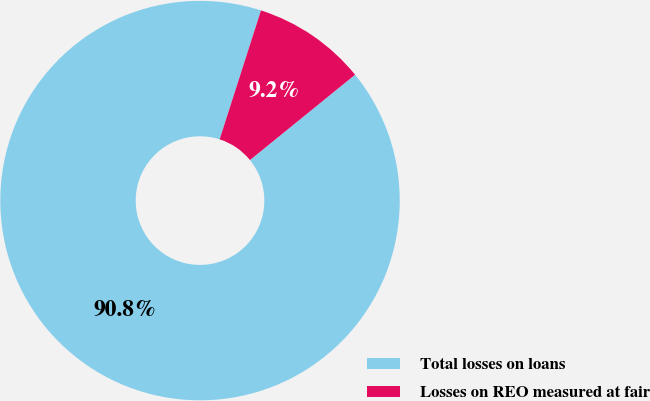Convert chart. <chart><loc_0><loc_0><loc_500><loc_500><pie_chart><fcel>Total losses on loans<fcel>Losses on REO measured at fair<nl><fcel>90.79%<fcel>9.21%<nl></chart> 